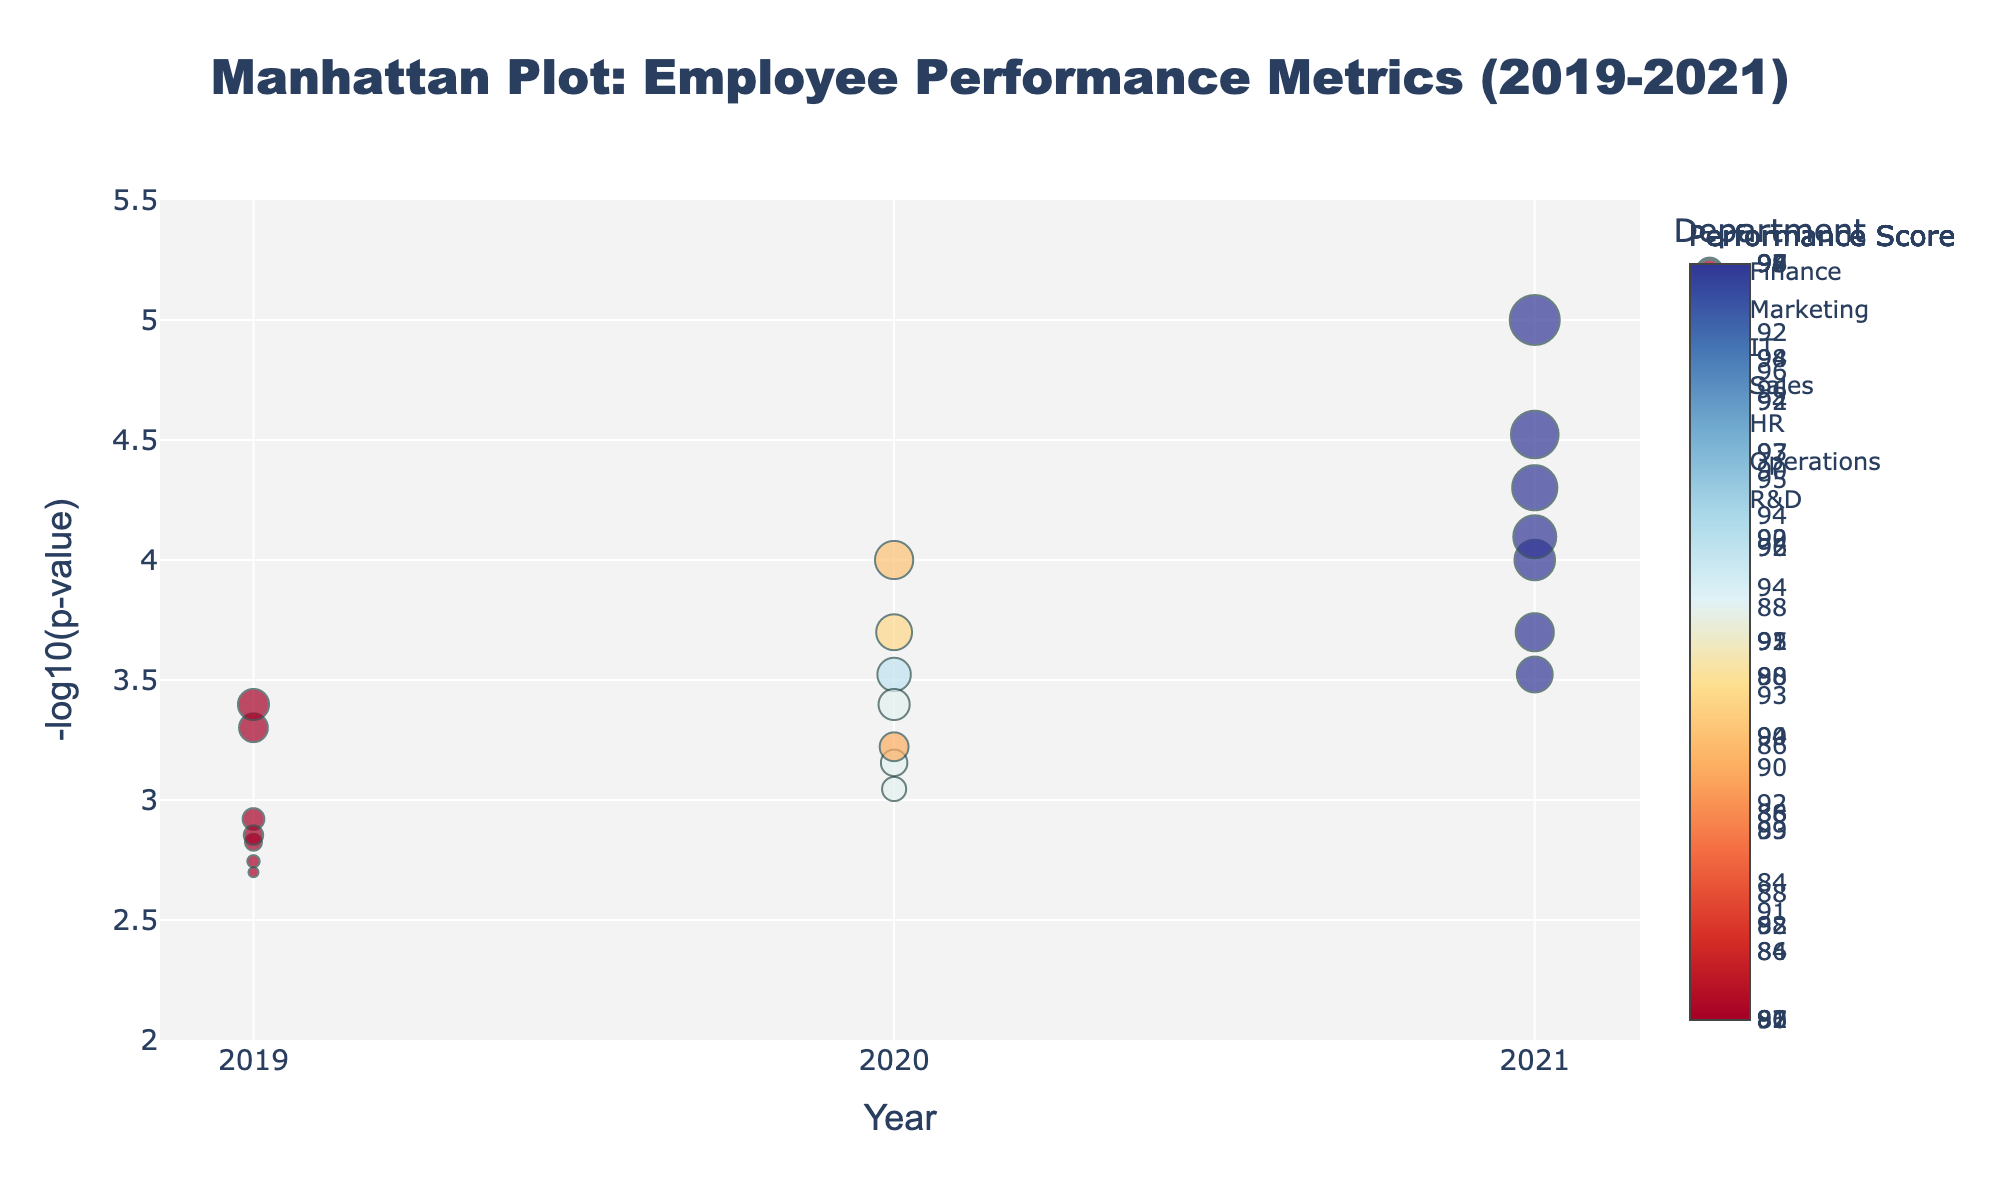What is the title of the figure? The title is placed at the top of the figure and is the largest, boldest text. It reads, "Manhattan Plot: Employee Performance Metrics (2019-2021)".
Answer: Manhattan Plot: Employee Performance Metrics (2019-2021) Which department has the highest performance score in 2021? By looking at the color bar and identifying the darkest blue dot for 2021, the department associated is R&D with the R&D Director position having the highest score.
Answer: R&D How many departments are represented in the plot? Each department is represented by a unique trace. By looking at the legend, there are markers for Finance, Marketing, IT, Sales, HR, Operations, and R&D.
Answer: 7 Which position has the smallest p-value and what is the corresponding performance score? By finding the data point with the highest -log10(p-value), which is highest on the y-axis, and noting its hover information, it corresponds to R&D Director in 2021 with a performance score of 99.
Answer: R&D Director, 99 What can you say about the trend for the IT department’s performance scores from 2019 to 2021? Look at the markers for the IT department from 2019 to 2021. The scores go from a lighter blue to darker blue indicating a trend of increasing performance scores.
Answer: Increasing How does the -log10(p-value) for Software Developer in IT compare to that of Accountant in Finance for 2019? Locate both points for 2019 and compare their y-values. The Software Developer has a higher -log10(p-value) than the Accountant.
Answer: Software Developer is higher What is the median performance score for all positions in 2020? Extract the performance scores for 2020: 92, 89, 93, 91, 88, 90, and 94. Sort them and find the middle value. The sorted scores are 88, 89, 90, 91, 92, 93, 94 and the median is 91.
Answer: 91 Which year had the lowest performance score in the Sales department? Look at the colors of the Sales department dots across the years. The lightest color corresponds to 2019.
Answer: 2019 Compare the 2020 performance score for the Marketing department's Brand Manager to the Finance department's Financial Analyst. Which is higher? Identify the dot for Brand Manager (2020) and Financial Analyst (2020) and compare their color. The Financial Analyst's dot is darker.
Answer: Financial Analyst 